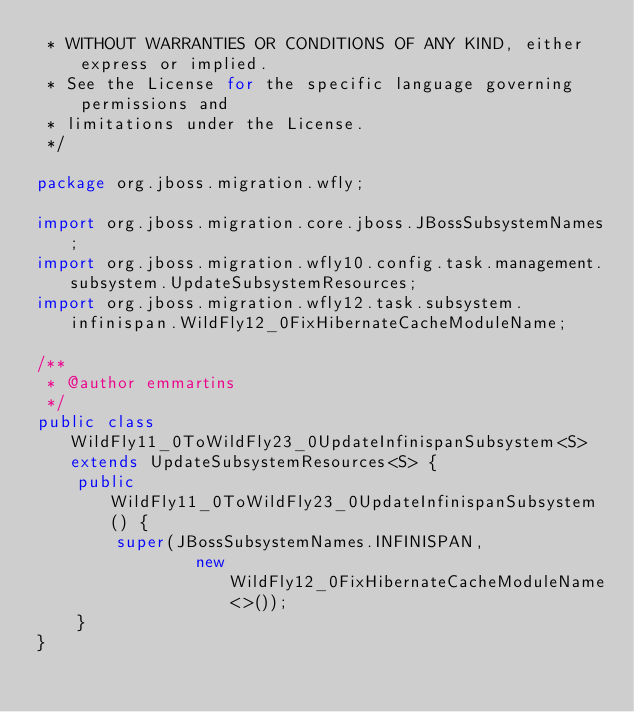<code> <loc_0><loc_0><loc_500><loc_500><_Java_> * WITHOUT WARRANTIES OR CONDITIONS OF ANY KIND, either express or implied.
 * See the License for the specific language governing permissions and
 * limitations under the License.
 */

package org.jboss.migration.wfly;

import org.jboss.migration.core.jboss.JBossSubsystemNames;
import org.jboss.migration.wfly10.config.task.management.subsystem.UpdateSubsystemResources;
import org.jboss.migration.wfly12.task.subsystem.infinispan.WildFly12_0FixHibernateCacheModuleName;

/**
 * @author emmartins
 */
public class WildFly11_0ToWildFly23_0UpdateInfinispanSubsystem<S> extends UpdateSubsystemResources<S> {
    public WildFly11_0ToWildFly23_0UpdateInfinispanSubsystem() {
        super(JBossSubsystemNames.INFINISPAN,
                new WildFly12_0FixHibernateCacheModuleName<>());
    }
}
</code> 